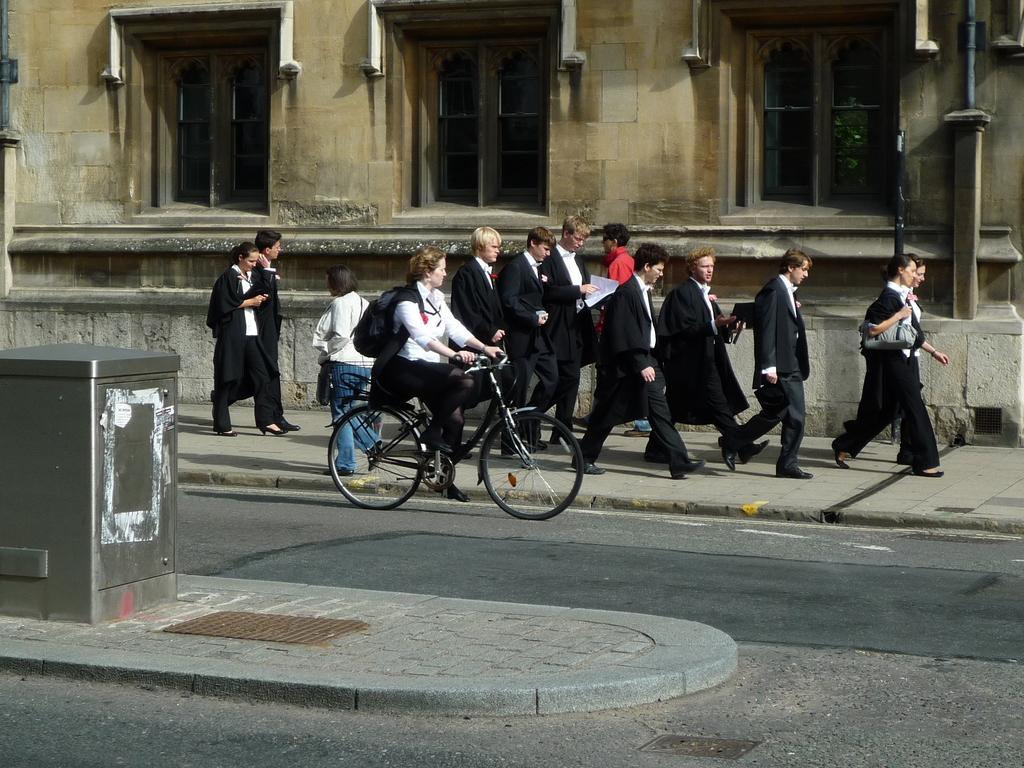Please provide a concise description of this image. In the middle of the image a woman riding a bicycle. Behind her a few people walking on the road. At the top of the image there is a building. This person holding a bag. 